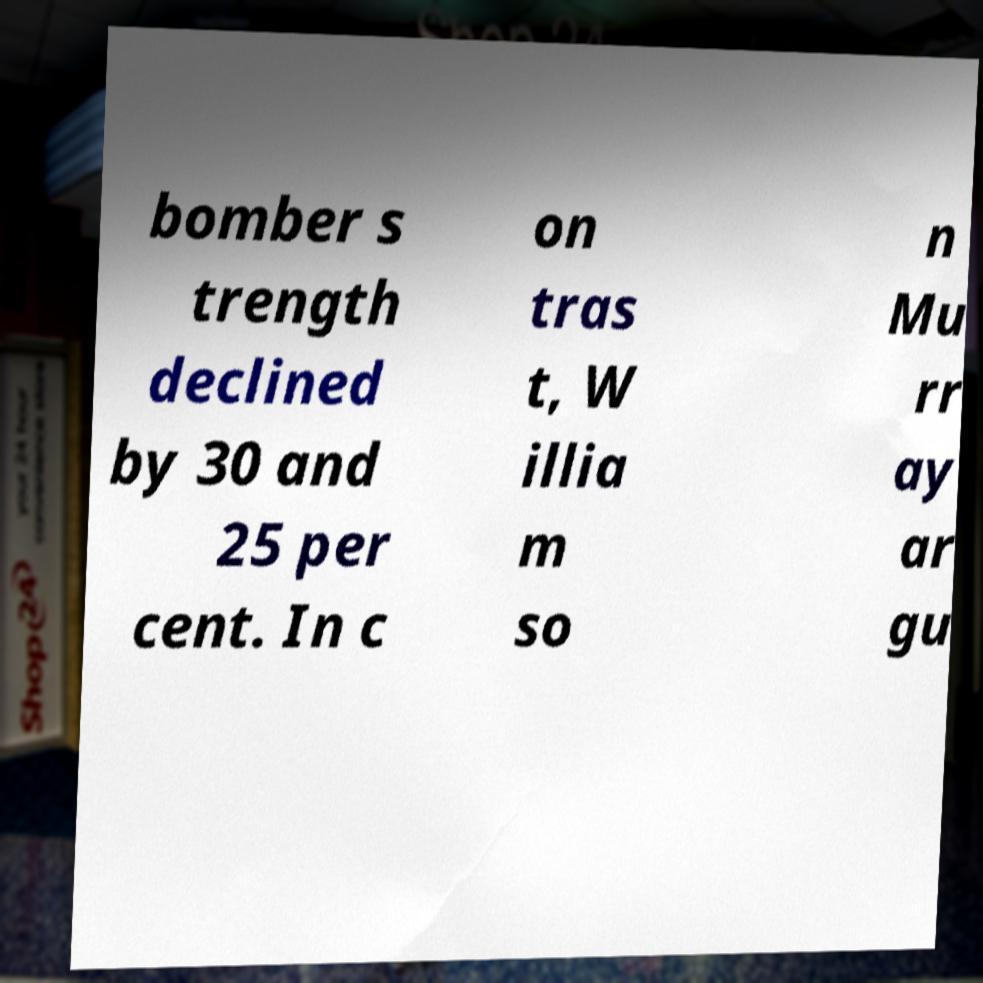Can you accurately transcribe the text from the provided image for me? bomber s trength declined by 30 and 25 per cent. In c on tras t, W illia m so n Mu rr ay ar gu 